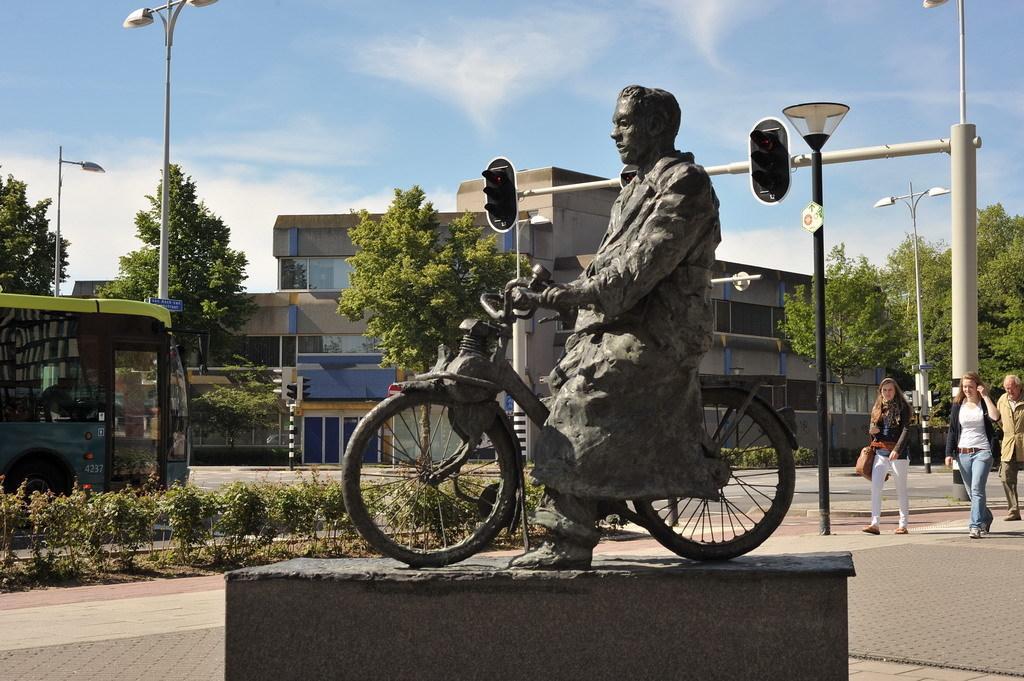In one or two sentences, can you explain what this image depicts? In the picture there is a statue of the man sitting on a cycle, behind the man there are three people walking on the footpath beside them there is a road ,a pillar, street lights, a building. On the road there is a bus, in background there are trees, sky and clouds. 